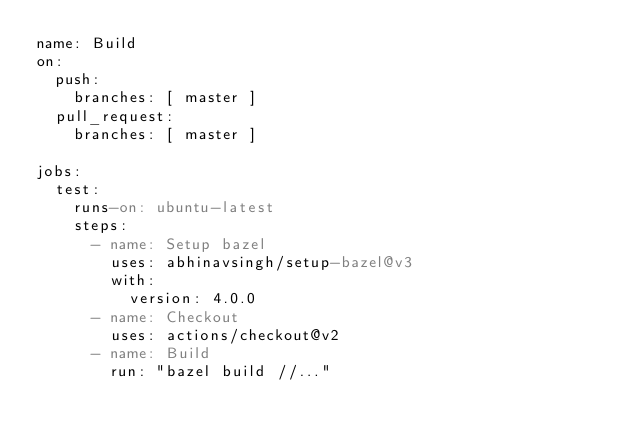<code> <loc_0><loc_0><loc_500><loc_500><_YAML_>name: Build
on:
  push:
    branches: [ master ]
  pull_request:
    branches: [ master ]

jobs:
  test:
    runs-on: ubuntu-latest
    steps:
      - name: Setup bazel
        uses: abhinavsingh/setup-bazel@v3
        with:
          version: 4.0.0
      - name: Checkout
        uses: actions/checkout@v2
      - name: Build
        run: "bazel build //..."
</code> 